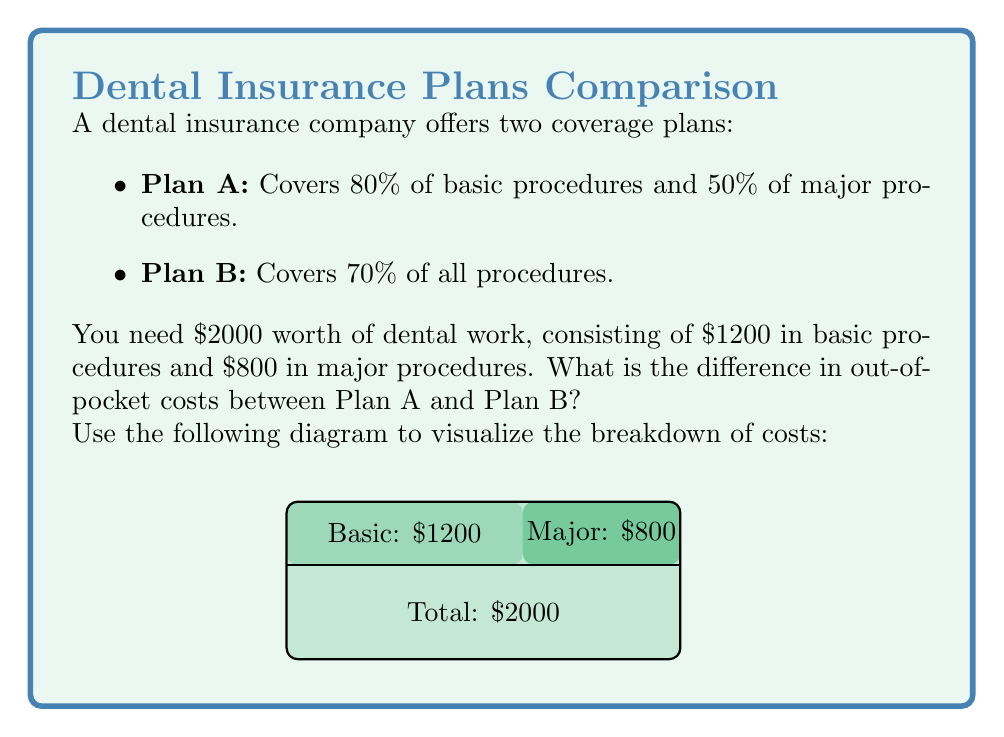What is the answer to this math problem? Let's solve this problem step by step:

1) For Plan A:
   - Basic procedures: $1200 × 80% = $960 covered
   - Major procedures: $800 × 50% = $400 covered
   - Total covered: $960 + $400 = $1360
   - Out-of-pocket cost: $2000 - $1360 = $640

2) For Plan B:
   - All procedures: $2000 × 70% = $1400 covered
   - Out-of-pocket cost: $2000 - $1400 = $600

3) To find the difference in out-of-pocket costs:
   $640 - $600 = $40

We can express this as a ratio to the total cost:

$$\frac{\text{Difference in out-of-pocket costs}}{\text{Total cost}} = \frac{40}{2000} = \frac{1}{50} = 0.02 = 2\%$$

This means the difference in out-of-pocket costs is 2% of the total dental work cost.
Answer: $40 or 2% of total cost 